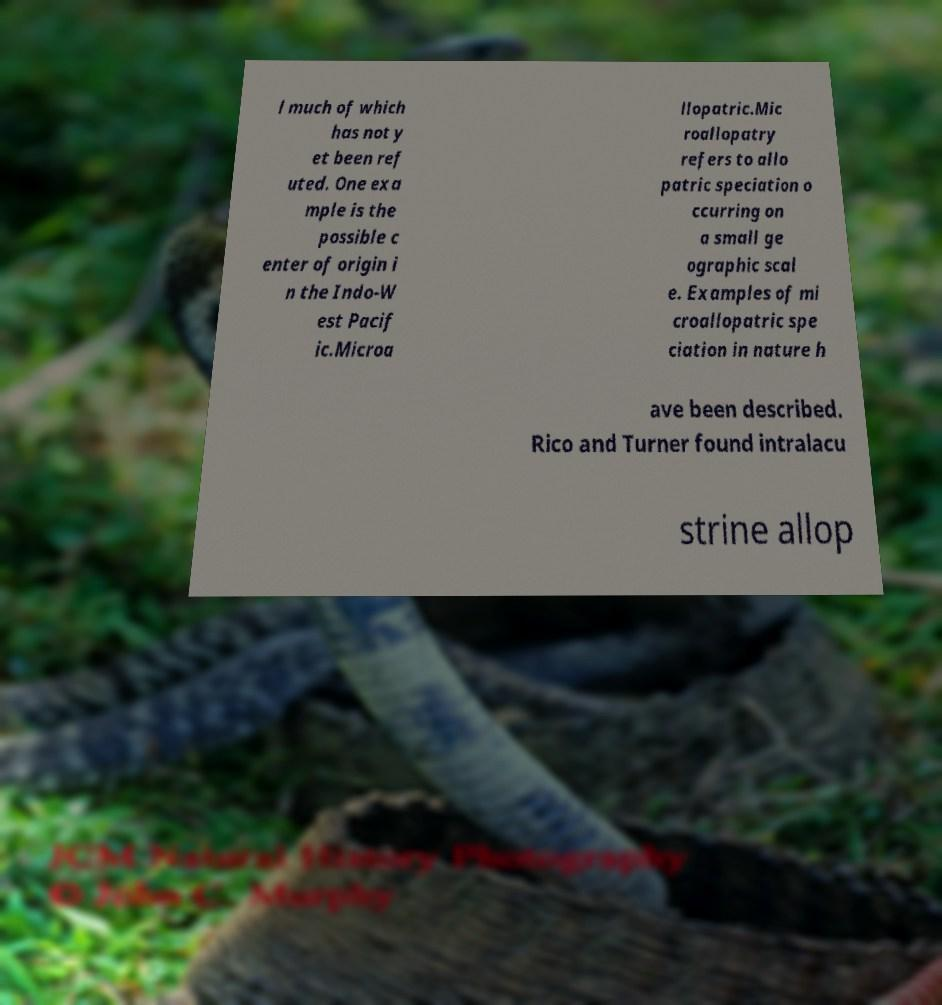What messages or text are displayed in this image? I need them in a readable, typed format. l much of which has not y et been ref uted. One exa mple is the possible c enter of origin i n the Indo-W est Pacif ic.Microa llopatric.Mic roallopatry refers to allo patric speciation o ccurring on a small ge ographic scal e. Examples of mi croallopatric spe ciation in nature h ave been described. Rico and Turner found intralacu strine allop 